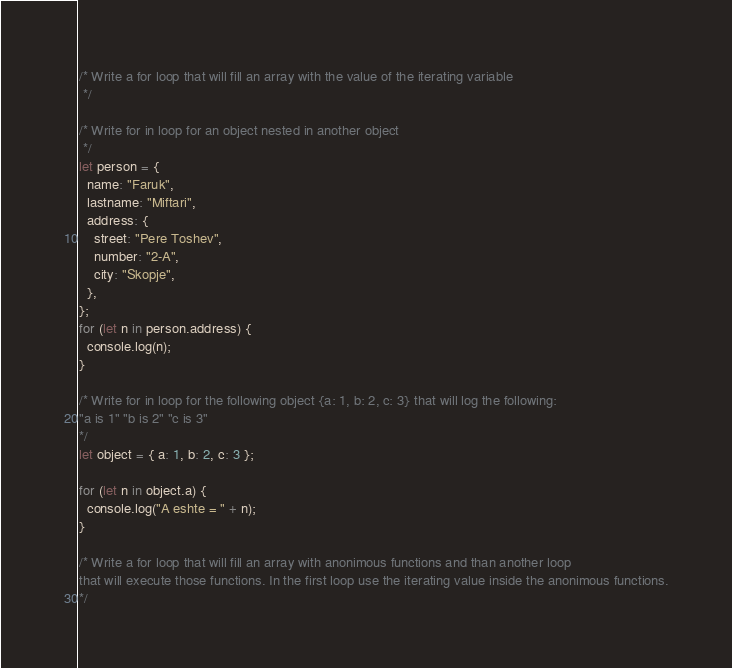<code> <loc_0><loc_0><loc_500><loc_500><_JavaScript_>/* Write a for loop that will fill an array with the value of the iterating variable
 */

/* Write for in loop for an object nested in another object
 */
let person = {
  name: "Faruk",
  lastname: "Miftari",
  address: {
    street: "Pere Toshev",
    number: "2-A",
    city: "Skopje",
  },
};
for (let n in person.address) {
  console.log(n);
}

/* Write for in loop for the following object {a: 1, b: 2, c: 3} that will log the following:
"a is 1" "b is 2" "c is 3"
*/
let object = { a: 1, b: 2, c: 3 };

for (let n in object.a) {
  console.log("A eshte = " + n);
}

/* Write a for loop that will fill an array with anonimous functions and than another loop
that will execute those functions. In the first loop use the iterating value inside the anonimous functions.
*/
</code> 